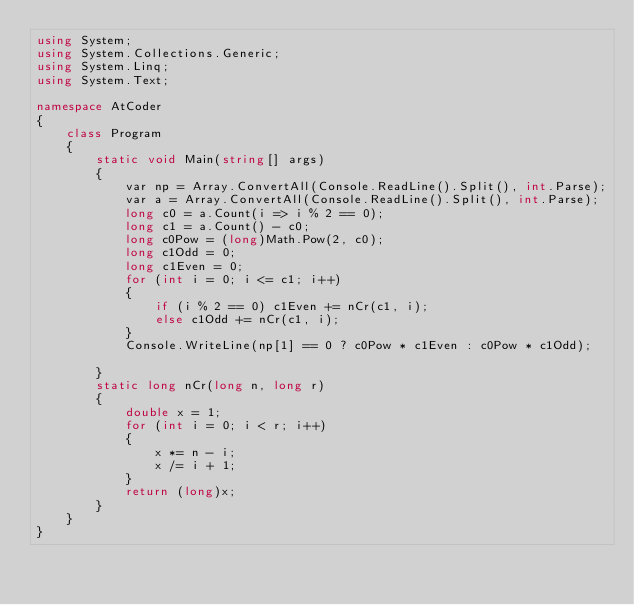Convert code to text. <code><loc_0><loc_0><loc_500><loc_500><_C#_>using System;
using System.Collections.Generic;
using System.Linq;
using System.Text;

namespace AtCoder
{
    class Program
    {
        static void Main(string[] args)
        {
            var np = Array.ConvertAll(Console.ReadLine().Split(), int.Parse);
            var a = Array.ConvertAll(Console.ReadLine().Split(), int.Parse);
            long c0 = a.Count(i => i % 2 == 0);
            long c1 = a.Count() - c0;
            long c0Pow = (long)Math.Pow(2, c0);
            long c1Odd = 0;
            long c1Even = 0;
            for (int i = 0; i <= c1; i++)
            {
                if (i % 2 == 0) c1Even += nCr(c1, i);
                else c1Odd += nCr(c1, i);
            }
            Console.WriteLine(np[1] == 0 ? c0Pow * c1Even : c0Pow * c1Odd);

        }
        static long nCr(long n, long r)
        {
            double x = 1;
            for (int i = 0; i < r; i++)
            {
                x *= n - i;
                x /= i + 1;
            }
            return (long)x;
        }
    }
}</code> 